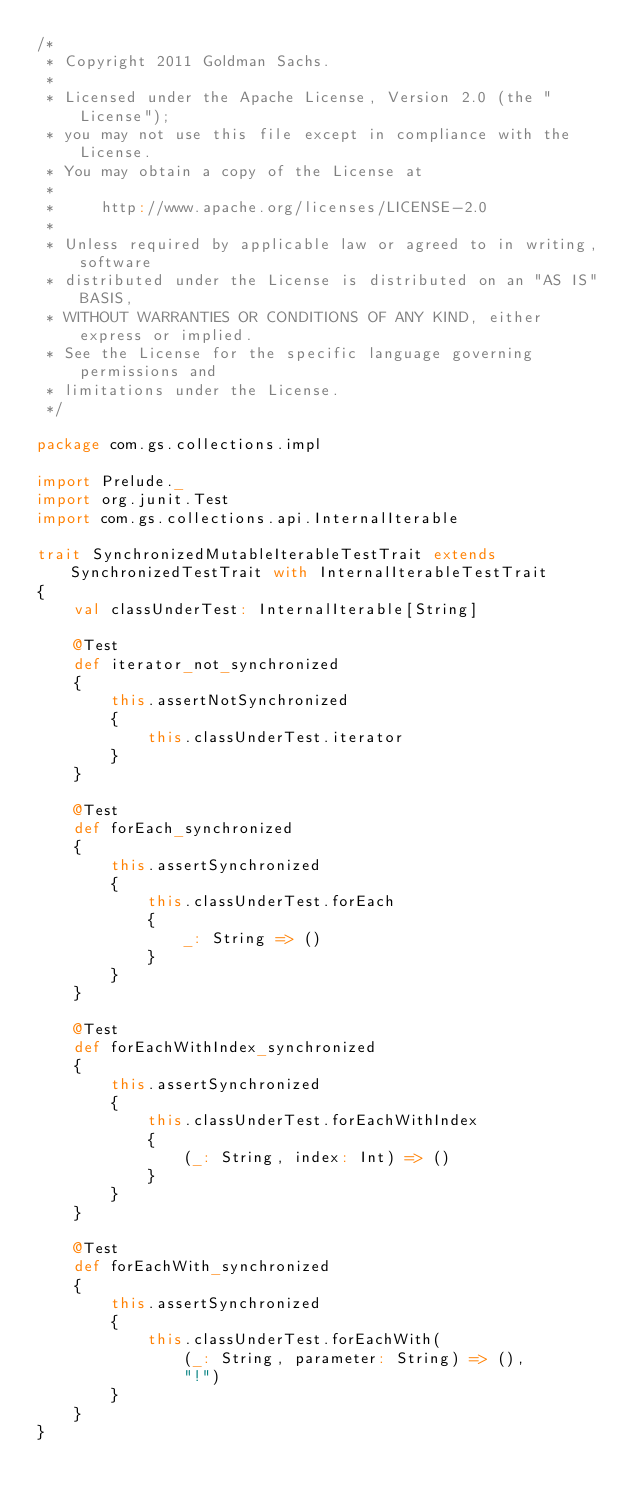Convert code to text. <code><loc_0><loc_0><loc_500><loc_500><_Scala_>/*
 * Copyright 2011 Goldman Sachs.
 *
 * Licensed under the Apache License, Version 2.0 (the "License");
 * you may not use this file except in compliance with the License.
 * You may obtain a copy of the License at
 *
 *     http://www.apache.org/licenses/LICENSE-2.0
 *
 * Unless required by applicable law or agreed to in writing, software
 * distributed under the License is distributed on an "AS IS" BASIS,
 * WITHOUT WARRANTIES OR CONDITIONS OF ANY KIND, either express or implied.
 * See the License for the specific language governing permissions and
 * limitations under the License.
 */

package com.gs.collections.impl

import Prelude._
import org.junit.Test
import com.gs.collections.api.InternalIterable

trait SynchronizedMutableIterableTestTrait extends SynchronizedTestTrait with InternalIterableTestTrait
{
    val classUnderTest: InternalIterable[String]

    @Test
    def iterator_not_synchronized
    {
        this.assertNotSynchronized
        {
            this.classUnderTest.iterator
        }
    }

    @Test
    def forEach_synchronized
    {
        this.assertSynchronized
        {
            this.classUnderTest.forEach
            {
                _: String => ()
            }
        }
    }

    @Test
    def forEachWithIndex_synchronized
    {
        this.assertSynchronized
        {
            this.classUnderTest.forEachWithIndex
            {
                (_: String, index: Int) => ()
            }
        }
    }

    @Test
    def forEachWith_synchronized
    {
        this.assertSynchronized
        {
            this.classUnderTest.forEachWith(
                (_: String, parameter: String) => (),
                "!")
        }
    }
}
</code> 